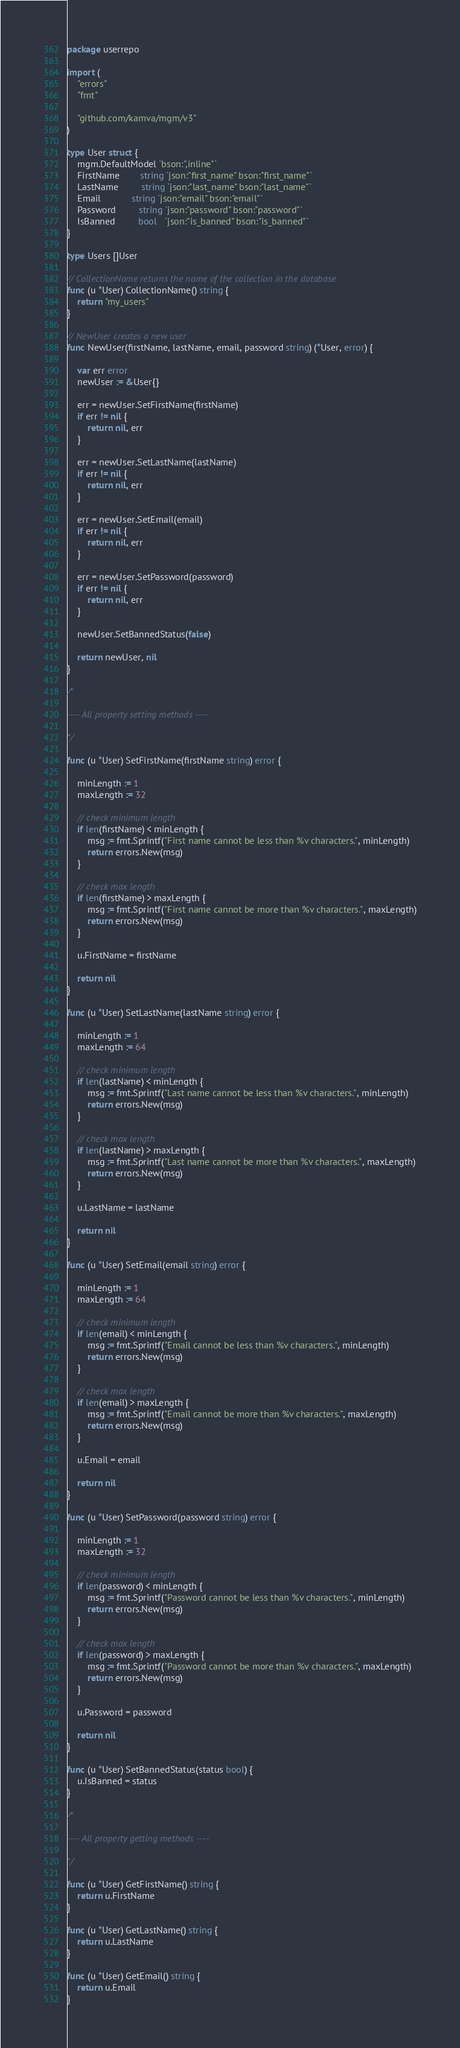<code> <loc_0><loc_0><loc_500><loc_500><_Go_>package userrepo

import (
	"errors"
	"fmt"

	"github.com/kamva/mgm/v3"
)

type User struct {
	mgm.DefaultModel `bson:",inline"`
	FirstName        string `json:"first_name" bson:"first_name"`
	LastName         string `json:"last_name" bson:"last_name"`
	Email            string `json:"email" bson:"email"`
	Password         string `json:"password" bson:"password"`
	IsBanned         bool   `json:"is_banned" bson:"is_banned"`
}

type Users []User

// CollectionName returns the name of the collection in the database
func (u *User) CollectionName() string {
	return "my_users"
}

// NewUser creates a new user
func NewUser(firstName, lastName, email, password string) (*User, error) {

	var err error
	newUser := &User{}

	err = newUser.SetFirstName(firstName)
	if err != nil {
		return nil, err
	}

	err = newUser.SetLastName(lastName)
	if err != nil {
		return nil, err
	}

	err = newUser.SetEmail(email)
	if err != nil {
		return nil, err
	}

	err = newUser.SetPassword(password)
	if err != nil {
		return nil, err
	}

	newUser.SetBannedStatus(false)

	return newUser, nil
}

/*

---- All property setting methods ----

*/

func (u *User) SetFirstName(firstName string) error {

	minLength := 1
	maxLength := 32

	// check minimum length
	if len(firstName) < minLength {
		msg := fmt.Sprintf("First name cannot be less than %v characters.", minLength)
		return errors.New(msg)
	}

	// check max length
	if len(firstName) > maxLength {
		msg := fmt.Sprintf("First name cannot be more than %v characters.", maxLength)
		return errors.New(msg)
	}

	u.FirstName = firstName

	return nil
}

func (u *User) SetLastName(lastName string) error {

	minLength := 1
	maxLength := 64

	// check minimum length
	if len(lastName) < minLength {
		msg := fmt.Sprintf("Last name cannot be less than %v characters.", minLength)
		return errors.New(msg)
	}

	// check max length
	if len(lastName) > maxLength {
		msg := fmt.Sprintf("Last name cannot be more than %v characters.", maxLength)
		return errors.New(msg)
	}

	u.LastName = lastName

	return nil
}

func (u *User) SetEmail(email string) error {

	minLength := 1
	maxLength := 64

	// check minimum length
	if len(email) < minLength {
		msg := fmt.Sprintf("Email cannot be less than %v characters.", minLength)
		return errors.New(msg)
	}

	// check max length
	if len(email) > maxLength {
		msg := fmt.Sprintf("Email cannot be more than %v characters.", maxLength)
		return errors.New(msg)
	}

	u.Email = email

	return nil
}

func (u *User) SetPassword(password string) error {

	minLength := 1
	maxLength := 32

	// check minimum length
	if len(password) < minLength {
		msg := fmt.Sprintf("Password cannot be less than %v characters.", minLength)
		return errors.New(msg)
	}

	// check max length
	if len(password) > maxLength {
		msg := fmt.Sprintf("Password cannot be more than %v characters.", maxLength)
		return errors.New(msg)
	}

	u.Password = password

	return nil
}

func (u *User) SetBannedStatus(status bool) {
	u.IsBanned = status
}

/*

---- All property getting methods ----

*/

func (u *User) GetFirstName() string {
	return u.FirstName
}

func (u *User) GetLastName() string {
	return u.LastName
}

func (u *User) GetEmail() string {
	return u.Email
}
</code> 